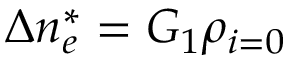Convert formula to latex. <formula><loc_0><loc_0><loc_500><loc_500>\Delta n _ { e } ^ { * } = G _ { 1 } \rho _ { i = 0 }</formula> 